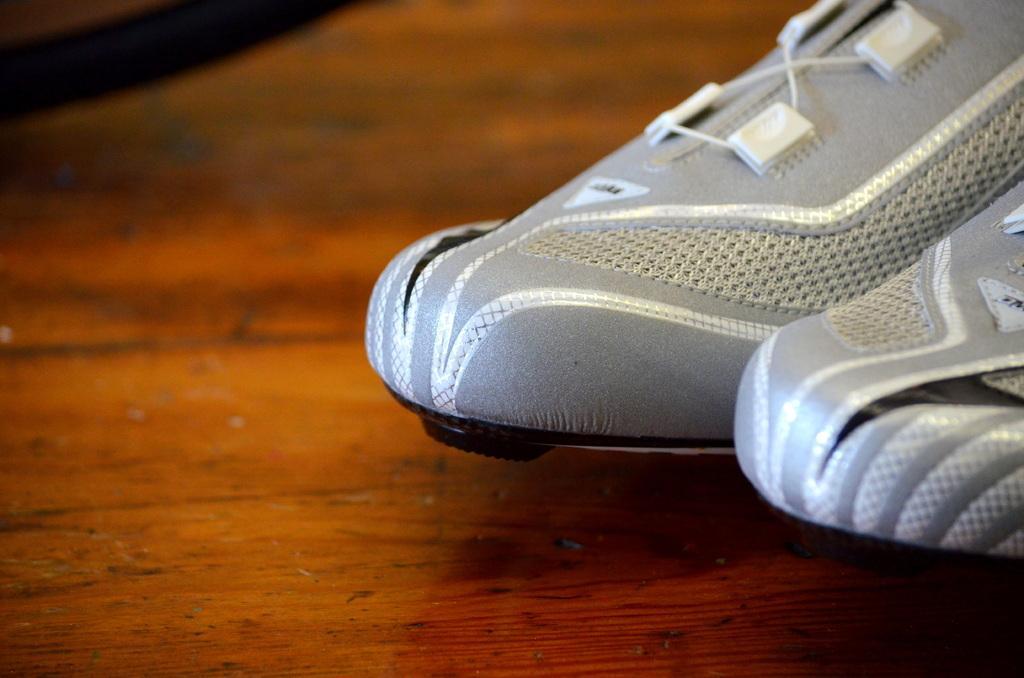How would you summarize this image in a sentence or two? In this image we can see sneakers placed on the surface. 